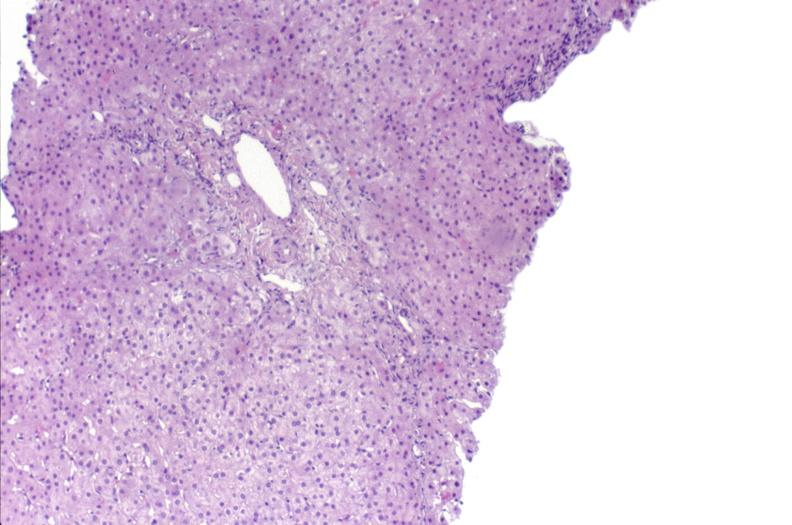does this image show ductopenia?
Answer the question using a single word or phrase. Yes 